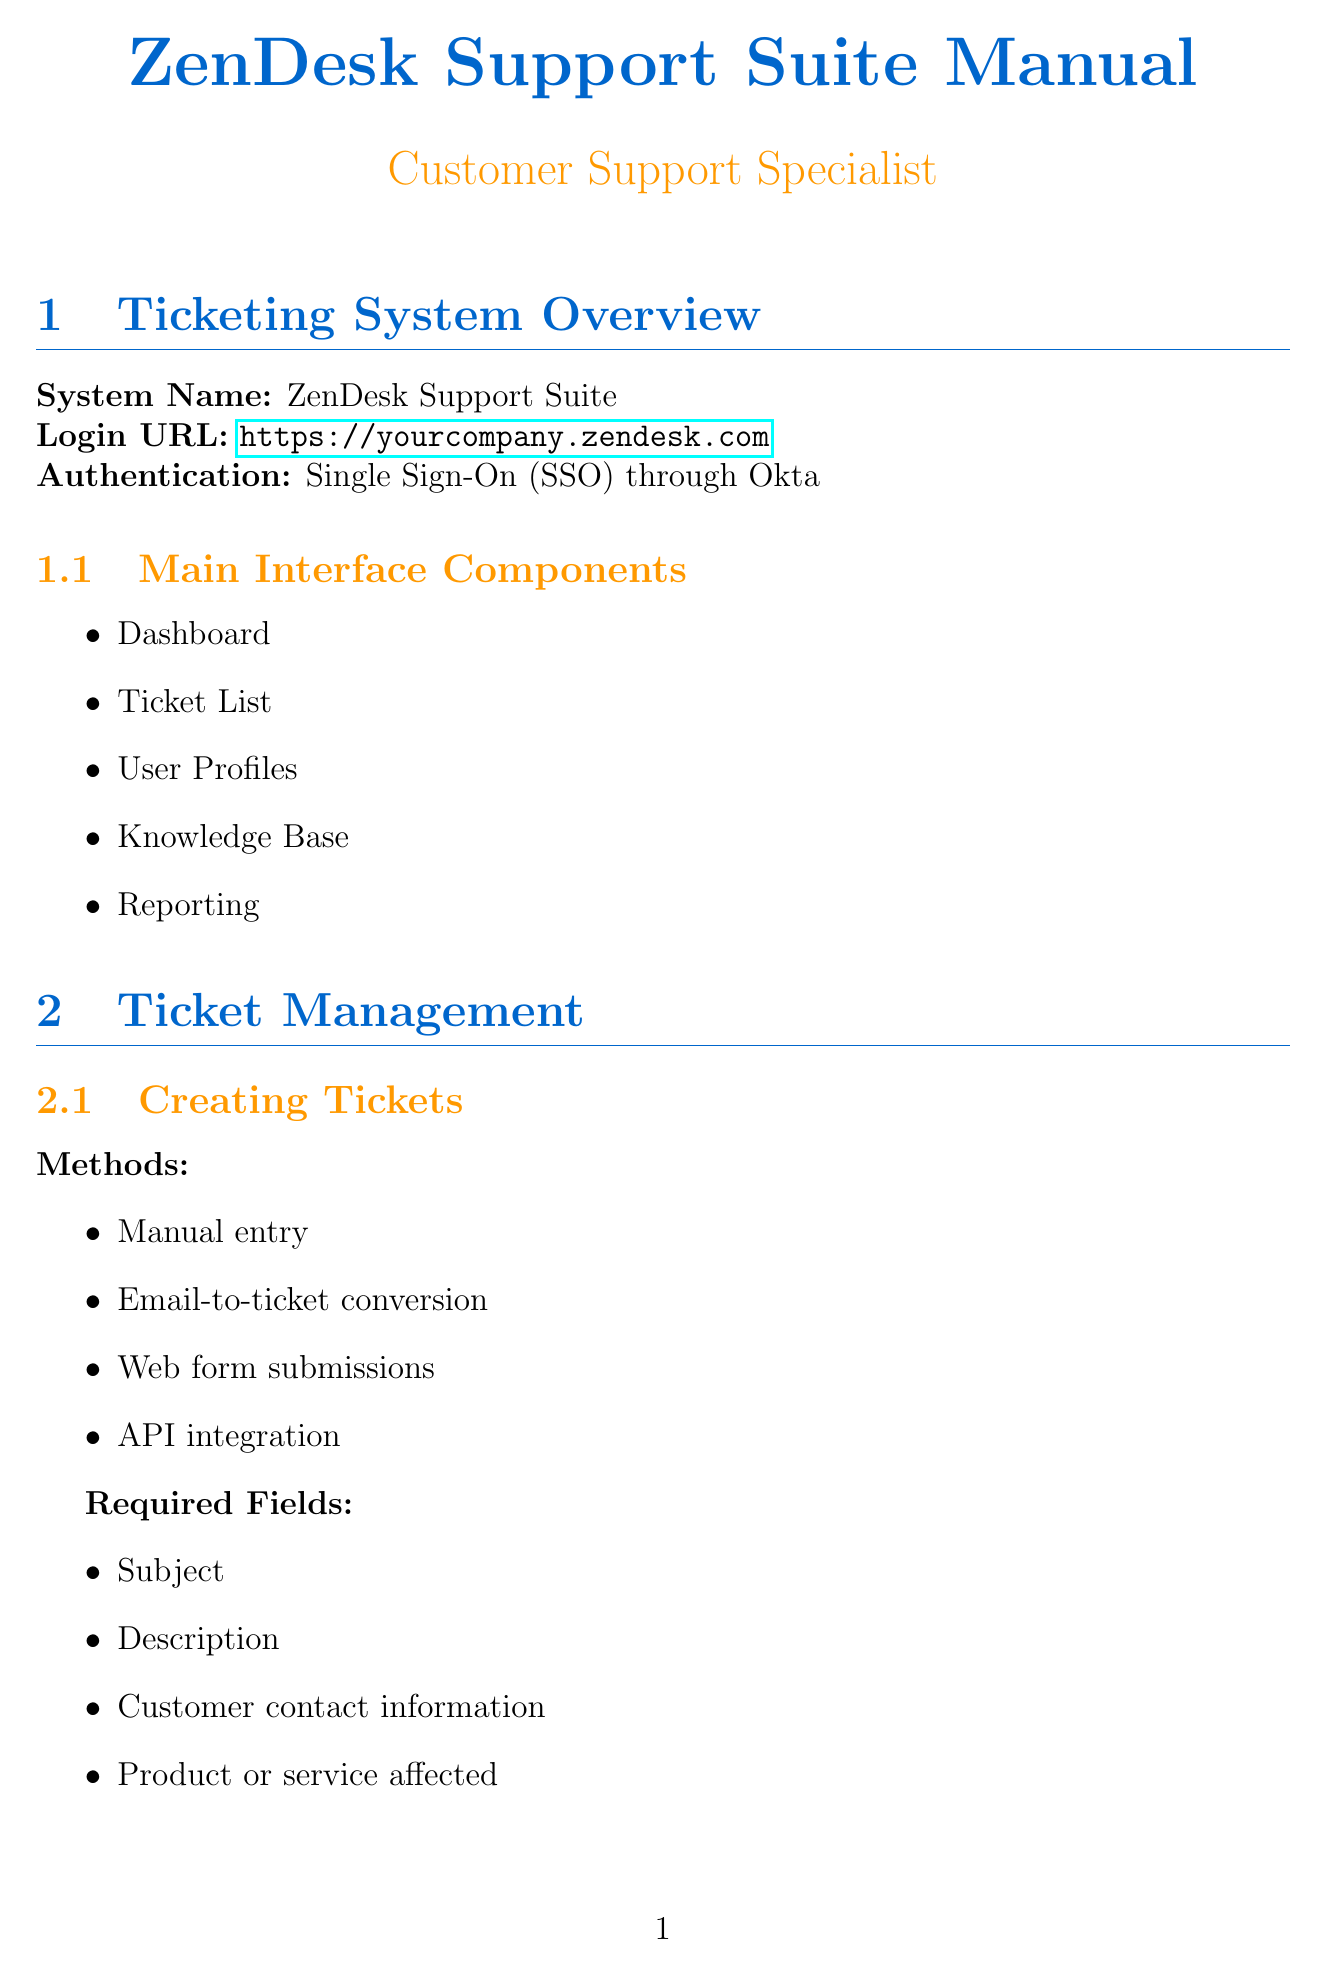What is the system name? The system name is specified in the overview section of the document.
Answer: ZenDesk Support Suite What is the URL for login? The URL for login is found in the ticketing system overview section.
Answer: https://yourcompany.zendesk.com What is the highest priority level? The priority levels listed in the document include Low, Medium, High, and Urgent, where Urgent is the highest.
Answer: Urgent What triggers an escalation? The escalation protocols section outlines several triggers, and one of them serves as a valid example.
Answer: SLA breach What does the communication tools section include? The communication tools section contains different tools for both internal and external communications.
Answer: Ticket comments (private notes) How many escalation levels are there? The escalation levels are listed in the escalation protocols section, allowing for a count of the levels mentioned.
Answer: Four How should tickets be assigned manually? The method for manual ticket assignment is described in the ticket management section.
Answer: Drag-and-drop or dropdown menu selection What is one factor affecting ticket priority? The document specifies factors affecting priority that include several considerations; thus, one example suffices.
Answer: Service Level Agreement (SLA) What is the purpose of canned responses? The canned responses section indicates their intended use within the ticketing process.
Answer: Standardized replies for common issues 